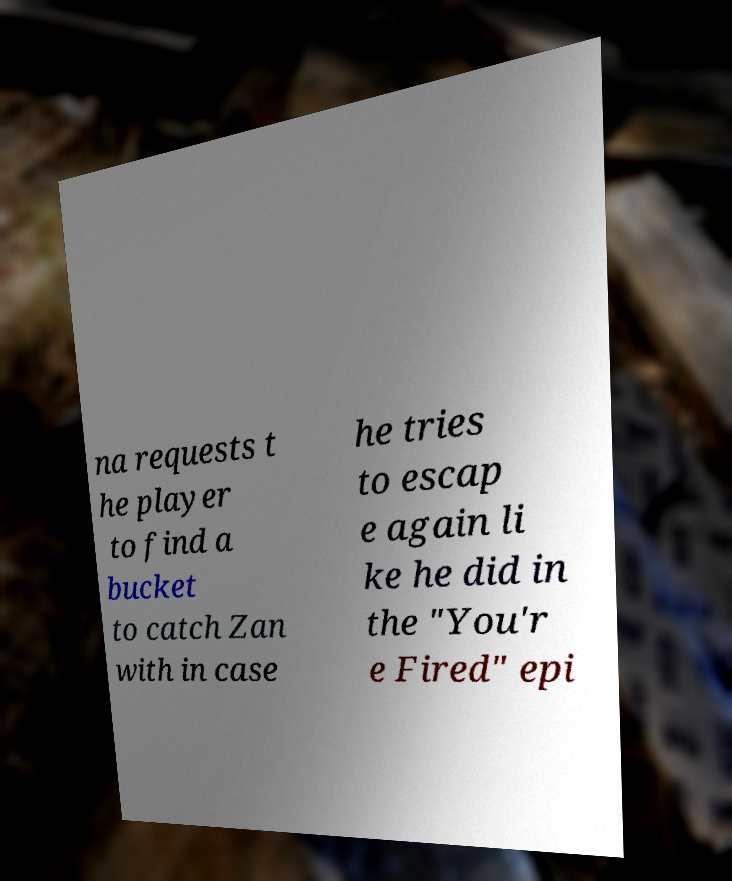Can you accurately transcribe the text from the provided image for me? na requests t he player to find a bucket to catch Zan with in case he tries to escap e again li ke he did in the "You'r e Fired" epi 